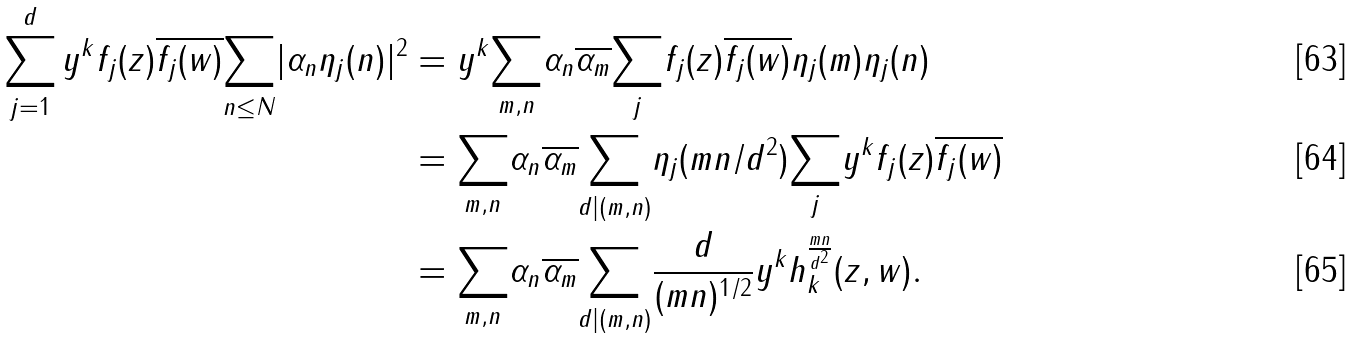Convert formula to latex. <formula><loc_0><loc_0><loc_500><loc_500>\sum _ { j = 1 } ^ { d } y ^ { k } f _ { j } ( z ) \overline { f _ { j } ( w ) } { \underset { n \leq N } \sum | \alpha _ { n } \eta _ { j } ( n ) | ^ { 2 } } & = y ^ { k } \underset { m , n } \sum \alpha _ { n } \overline { \alpha _ { m } } \underset { j } \sum f _ { j } ( z ) \overline { f _ { j } ( w ) } \eta _ { j } ( m ) \eta _ { j } ( n ) \\ & = \underset { m , n } \sum \alpha _ { n } \overline { \alpha _ { m } } \underset { d | ( m , n ) } \sum \eta _ { j } ( m n / d ^ { 2 } ) \underset { j } \sum y ^ { k } f _ { j } ( z ) \overline { f _ { j } ( w ) } \\ & = \underset { m , n } \sum \alpha _ { n } \overline { \alpha _ { m } } \underset { d | ( m , n ) } \sum \frac { d } { ( m n ) ^ { 1 / 2 } } y ^ { k } h ^ { \frac { m n } { d ^ { 2 } } } _ { k } ( z , w ) .</formula> 